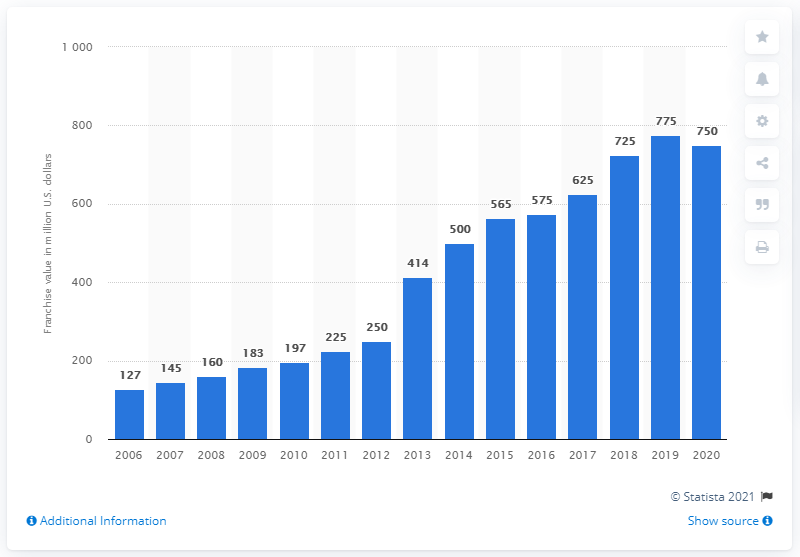List a handful of essential elements in this visual. In 2020, the value of the Washington Capitals franchise was approximately $750 million dollars. 